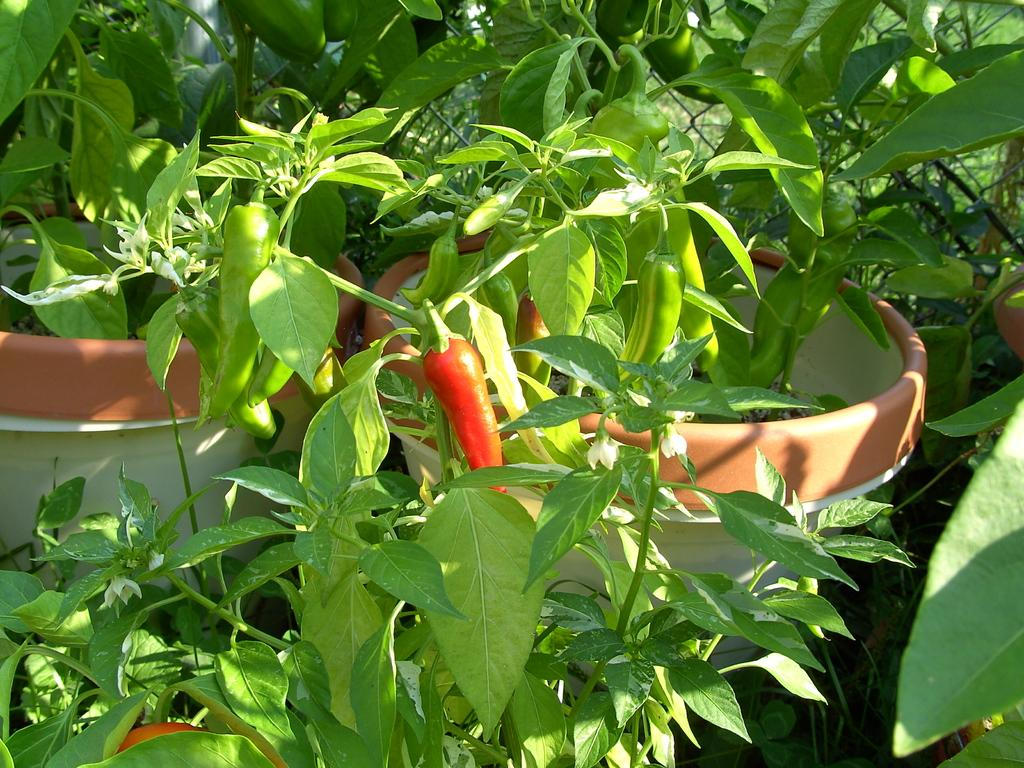What type of plants are in the image? There are chili plants in the image. Where are the chili plants located? The chili plants are in flower pots. What type of blade is used to harvest the chili plants in the image? There is no blade present in the image, as the chili plants are in flower pots. 